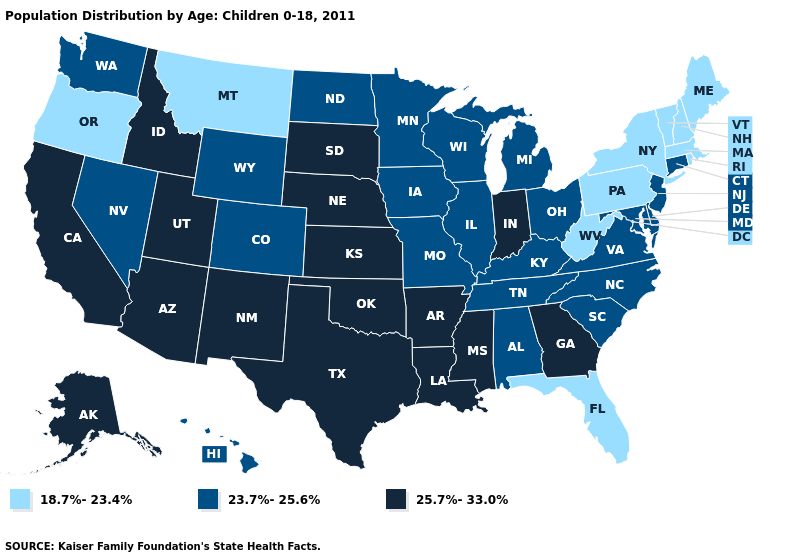What is the value of California?
Short answer required. 25.7%-33.0%. Does Tennessee have a higher value than Pennsylvania?
Answer briefly. Yes. Name the states that have a value in the range 25.7%-33.0%?
Give a very brief answer. Alaska, Arizona, Arkansas, California, Georgia, Idaho, Indiana, Kansas, Louisiana, Mississippi, Nebraska, New Mexico, Oklahoma, South Dakota, Texas, Utah. What is the value of Nevada?
Quick response, please. 23.7%-25.6%. Which states have the lowest value in the Northeast?
Answer briefly. Maine, Massachusetts, New Hampshire, New York, Pennsylvania, Rhode Island, Vermont. Name the states that have a value in the range 23.7%-25.6%?
Be succinct. Alabama, Colorado, Connecticut, Delaware, Hawaii, Illinois, Iowa, Kentucky, Maryland, Michigan, Minnesota, Missouri, Nevada, New Jersey, North Carolina, North Dakota, Ohio, South Carolina, Tennessee, Virginia, Washington, Wisconsin, Wyoming. How many symbols are there in the legend?
Be succinct. 3. Does the first symbol in the legend represent the smallest category?
Short answer required. Yes. What is the value of Rhode Island?
Write a very short answer. 18.7%-23.4%. What is the value of North Dakota?
Write a very short answer. 23.7%-25.6%. Name the states that have a value in the range 23.7%-25.6%?
Write a very short answer. Alabama, Colorado, Connecticut, Delaware, Hawaii, Illinois, Iowa, Kentucky, Maryland, Michigan, Minnesota, Missouri, Nevada, New Jersey, North Carolina, North Dakota, Ohio, South Carolina, Tennessee, Virginia, Washington, Wisconsin, Wyoming. What is the highest value in states that border Nevada?
Concise answer only. 25.7%-33.0%. Does Kentucky have the lowest value in the USA?
Quick response, please. No. Does the map have missing data?
Give a very brief answer. No. Does Nebraska have the highest value in the MidWest?
Write a very short answer. Yes. 